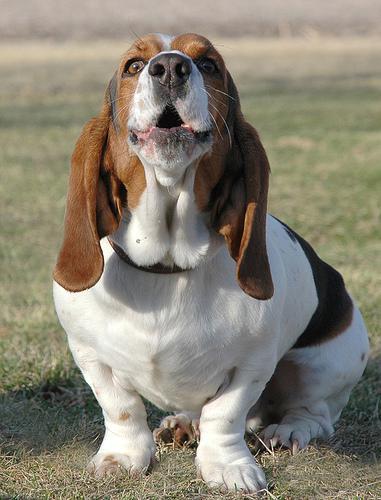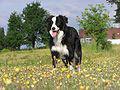The first image is the image on the left, the second image is the image on the right. Examine the images to the left and right. Is the description "There are 2 dogs outdoors on the grass." accurate? Answer yes or no. Yes. The first image is the image on the left, the second image is the image on the right. Assess this claim about the two images: "One of the images shows a basset hound with its body pointed toward the right.". Correct or not? Answer yes or no. No. 